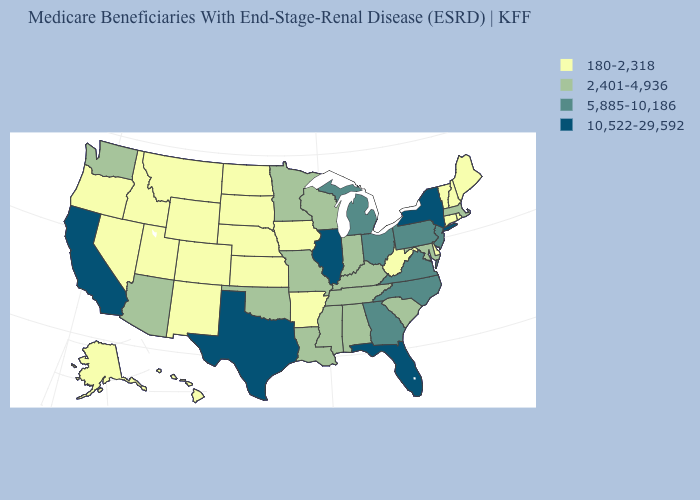Name the states that have a value in the range 2,401-4,936?
Be succinct. Alabama, Arizona, Indiana, Kentucky, Louisiana, Maryland, Massachusetts, Minnesota, Mississippi, Missouri, Oklahoma, South Carolina, Tennessee, Washington, Wisconsin. Does Colorado have the lowest value in the USA?
Quick response, please. Yes. Among the states that border Alabama , which have the highest value?
Give a very brief answer. Florida. Name the states that have a value in the range 180-2,318?
Write a very short answer. Alaska, Arkansas, Colorado, Connecticut, Delaware, Hawaii, Idaho, Iowa, Kansas, Maine, Montana, Nebraska, Nevada, New Hampshire, New Mexico, North Dakota, Oregon, Rhode Island, South Dakota, Utah, Vermont, West Virginia, Wyoming. How many symbols are there in the legend?
Short answer required. 4. Name the states that have a value in the range 10,522-29,592?
Write a very short answer. California, Florida, Illinois, New York, Texas. What is the value of California?
Quick response, please. 10,522-29,592. Name the states that have a value in the range 5,885-10,186?
Concise answer only. Georgia, Michigan, New Jersey, North Carolina, Ohio, Pennsylvania, Virginia. What is the value of New Mexico?
Quick response, please. 180-2,318. What is the lowest value in states that border Ohio?
Short answer required. 180-2,318. Does Arkansas have the lowest value in the South?
Write a very short answer. Yes. What is the lowest value in the USA?
Answer briefly. 180-2,318. Does South Dakota have a higher value than Oklahoma?
Short answer required. No. Does Iowa have a lower value than Georgia?
Be succinct. Yes. Name the states that have a value in the range 2,401-4,936?
Keep it brief. Alabama, Arizona, Indiana, Kentucky, Louisiana, Maryland, Massachusetts, Minnesota, Mississippi, Missouri, Oklahoma, South Carolina, Tennessee, Washington, Wisconsin. 